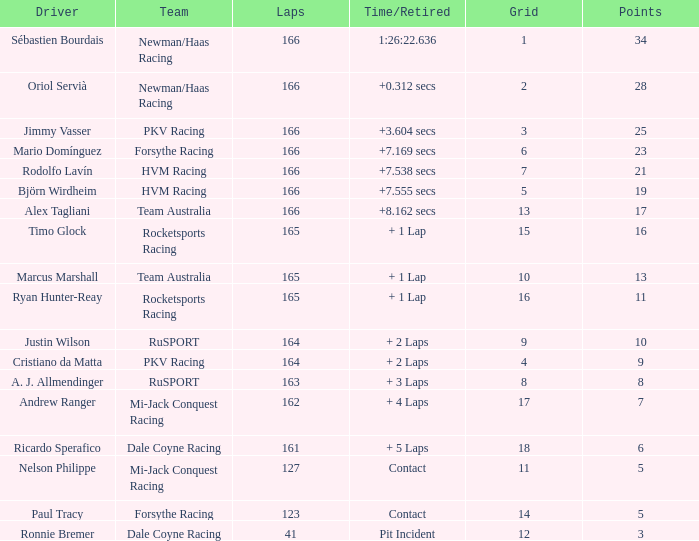What grid is the lowest when the time/retired is + 5 laps and the laps is less than 161? None. 